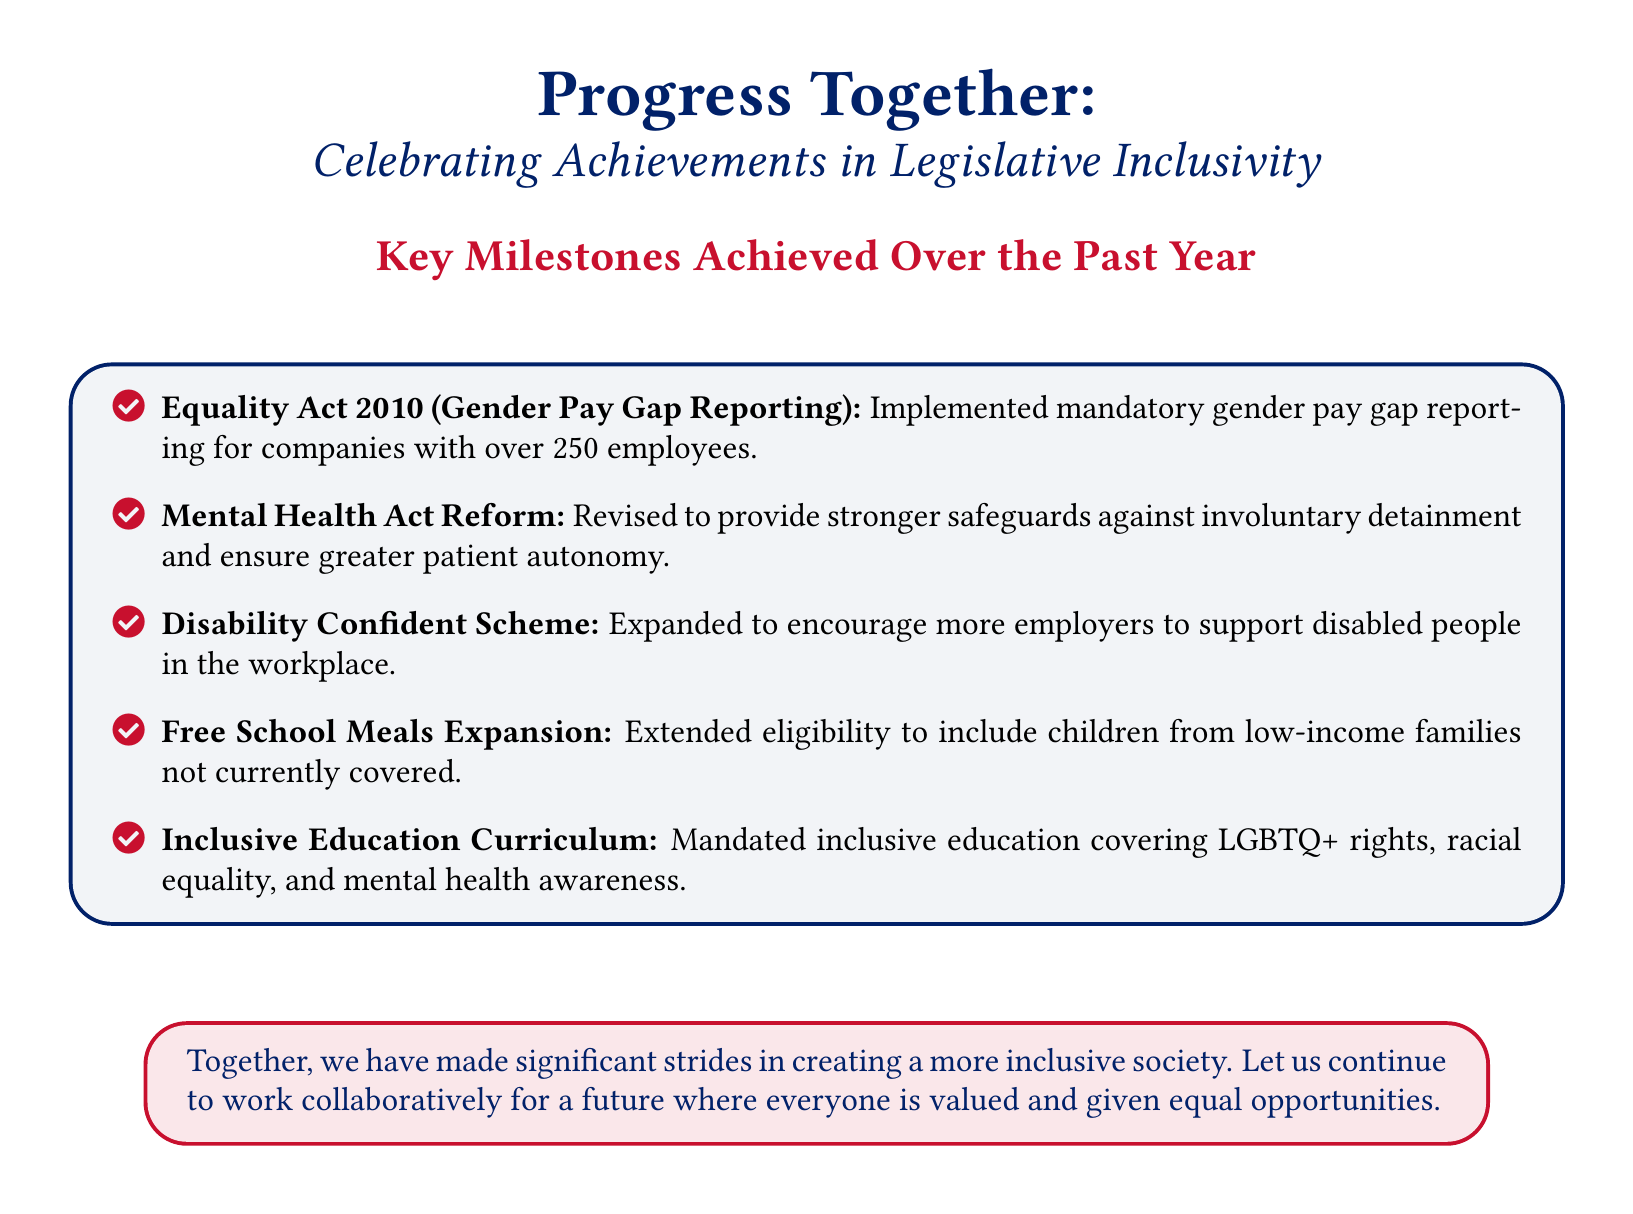What is the title of the document? The title of the document is prominently displayed at the top and reads "Progress Together."
Answer: Progress Together What is the primary focus of the document? The document's focus is to celebrate achievements in legislative inclusivity.
Answer: Legislative inclusivity How many key milestones are listed? The document lists several achievements, and counting them provides the total number of milestones.
Answer: Five What act was revised for stronger safeguards in mental health? The specific act mentioned in the document regarding mental health reforms is detailed.
Answer: Mental Health Act What does the Inclusive Education Curriculum cover? The document specifies certain rights and issues that the curriculum mandates, indicating its scope.
Answer: LGBTQ+ rights, racial equality, and mental health awareness What scheme was expanded to support disabled people? The name of the scheme aimed at encouraging employer support is included in the achievements.
Answer: Disability Confident Scheme What is the color scheme used in the document? The colors used throughout the document are referred to in the elements and design of the card.
Answer: British blue and British red What is the encouraging message in the card? The final message in the card emphasizes a collaborative effort for future inclusivity.
Answer: Together, we have made significant strides in creating a more inclusive society What year are the achievements from? The achievements celebrated in the document are specifically from the past year, as noted.
Answer: Past year 